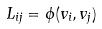<formula> <loc_0><loc_0><loc_500><loc_500>L _ { i j } = \phi ( v _ { i } , v _ { j } )</formula> 